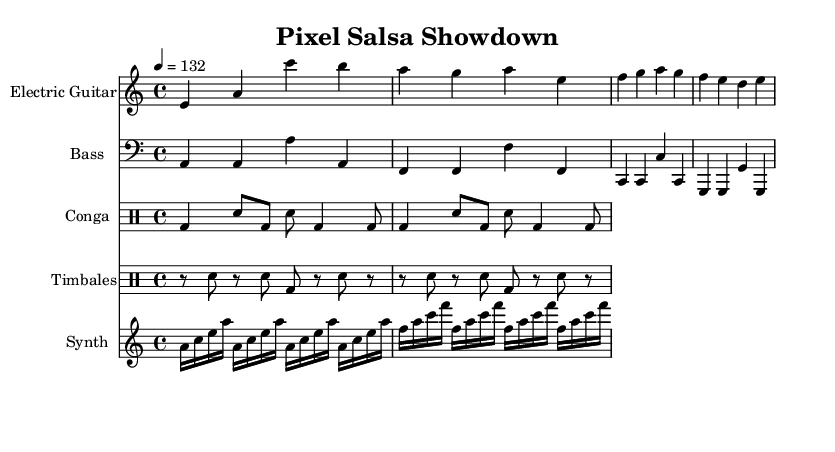What is the key signature of this music? The key signature is A minor, which contains no sharps or flats. This is determined from the global music directives in the sheet music specifying the key.
Answer: A minor What is the time signature of this music? The time signature is 4/4, which can be found in the global music directives. This means there are four beats per measure and the quarter note gets one beat.
Answer: 4/4 What is the tempo marking in this score? The tempo marking is 132 beats per minute, indicated in the global directives as "4 = 132." This specifies the speed of the music.
Answer: 132 How many measures are in the electric guitar part? The electric guitar part consists of four measures. Each measure contains the notes specified in the sequence listed, allowing us to count them.
Answer: 4 What instruments are included in the score? The instruments included are Electric Guitar, Bass, Conga, Timbales, and Synth. This can be determined by looking at the instrument names listed in each staff of the score.
Answer: Electric Guitar, Bass, Conga, Timbales, Synth What rhythmic feature is prominent in the conga part? The prominent rhythmic feature in the conga part is the use of the bass drum and snare hit alternation. This rhythm creates a characteristic pattern typical of Latin music, specifically seen in the conga notation.
Answer: Bass drum and snare hit alternation Which instrument uses the highest pitch range? The synth part uses the highest pitch range with notes starting from an A two octaves above middle C. This is determined by the relative pitch notation in the staff and the notes written.
Answer: Synth 